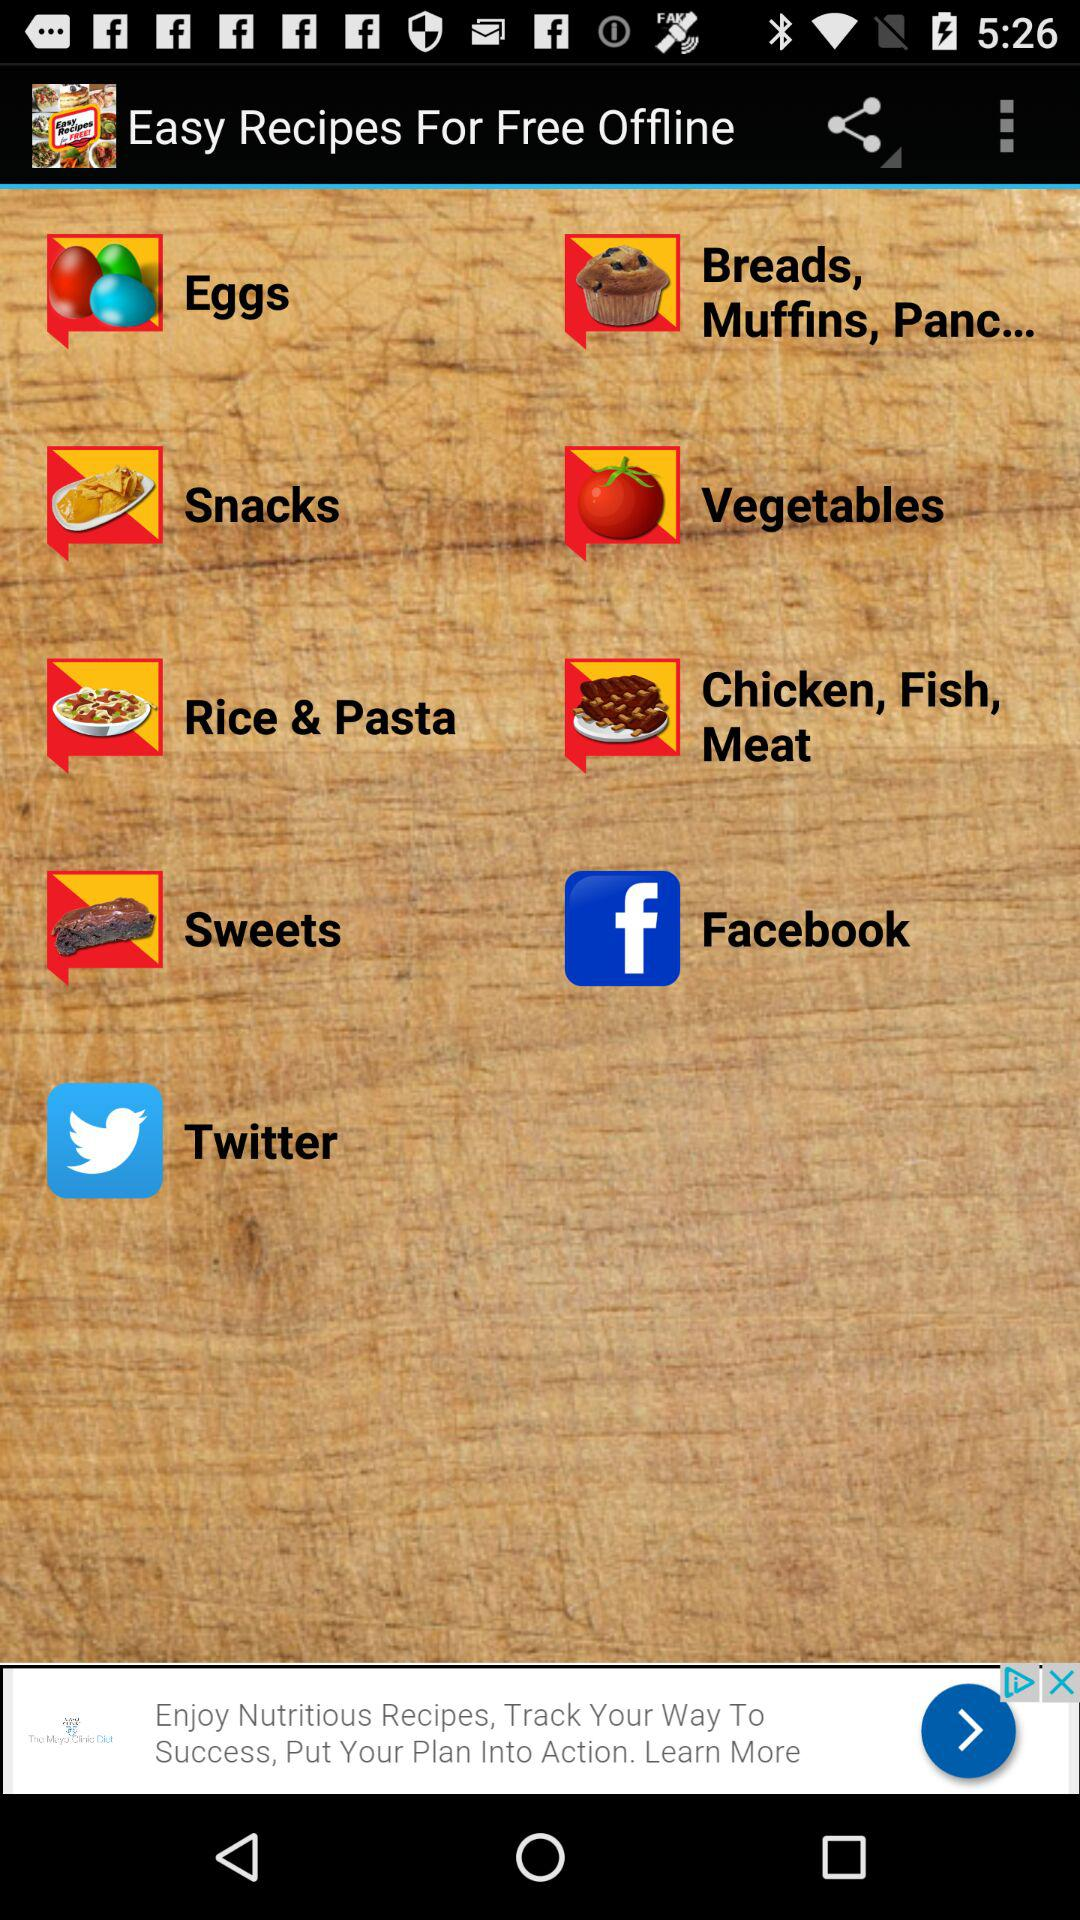What is the application name? The application name is "Easy Recipes For Free Offline". 